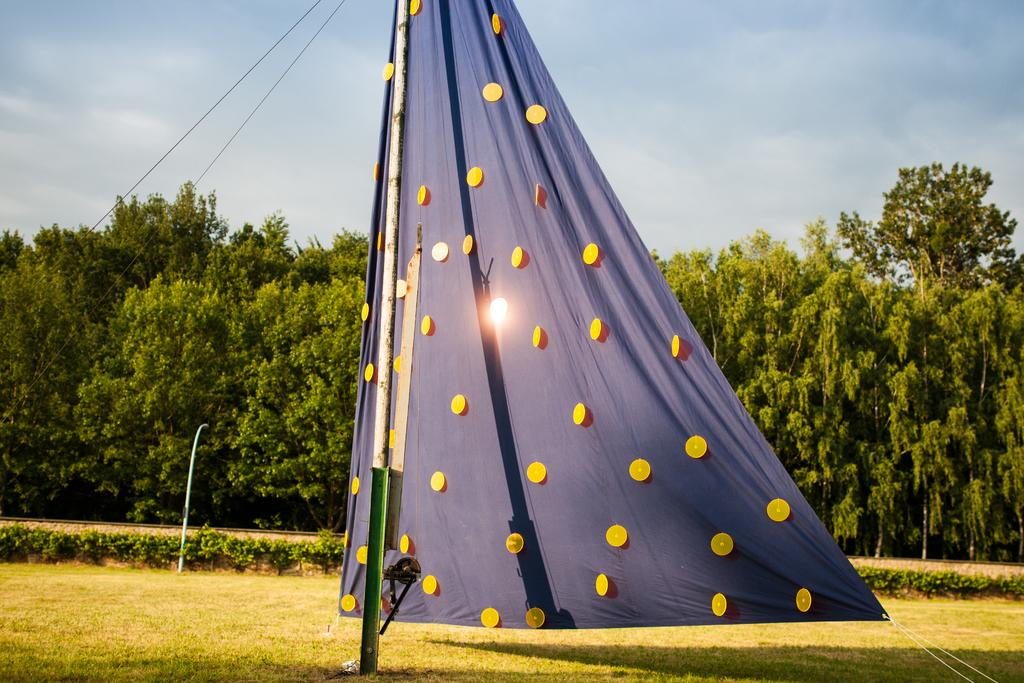What is the main structure in the center of the image? There is a tent in the center of the image. What type of terrain is visible at the bottom of the image? There is grassland at the bottom side of the image. What can be seen in the background of the image? There are trees in the background area of the image. What memory does the tent evoke for the person in the image? There is no indication in the image that the person has any specific memory associated with the tent. 